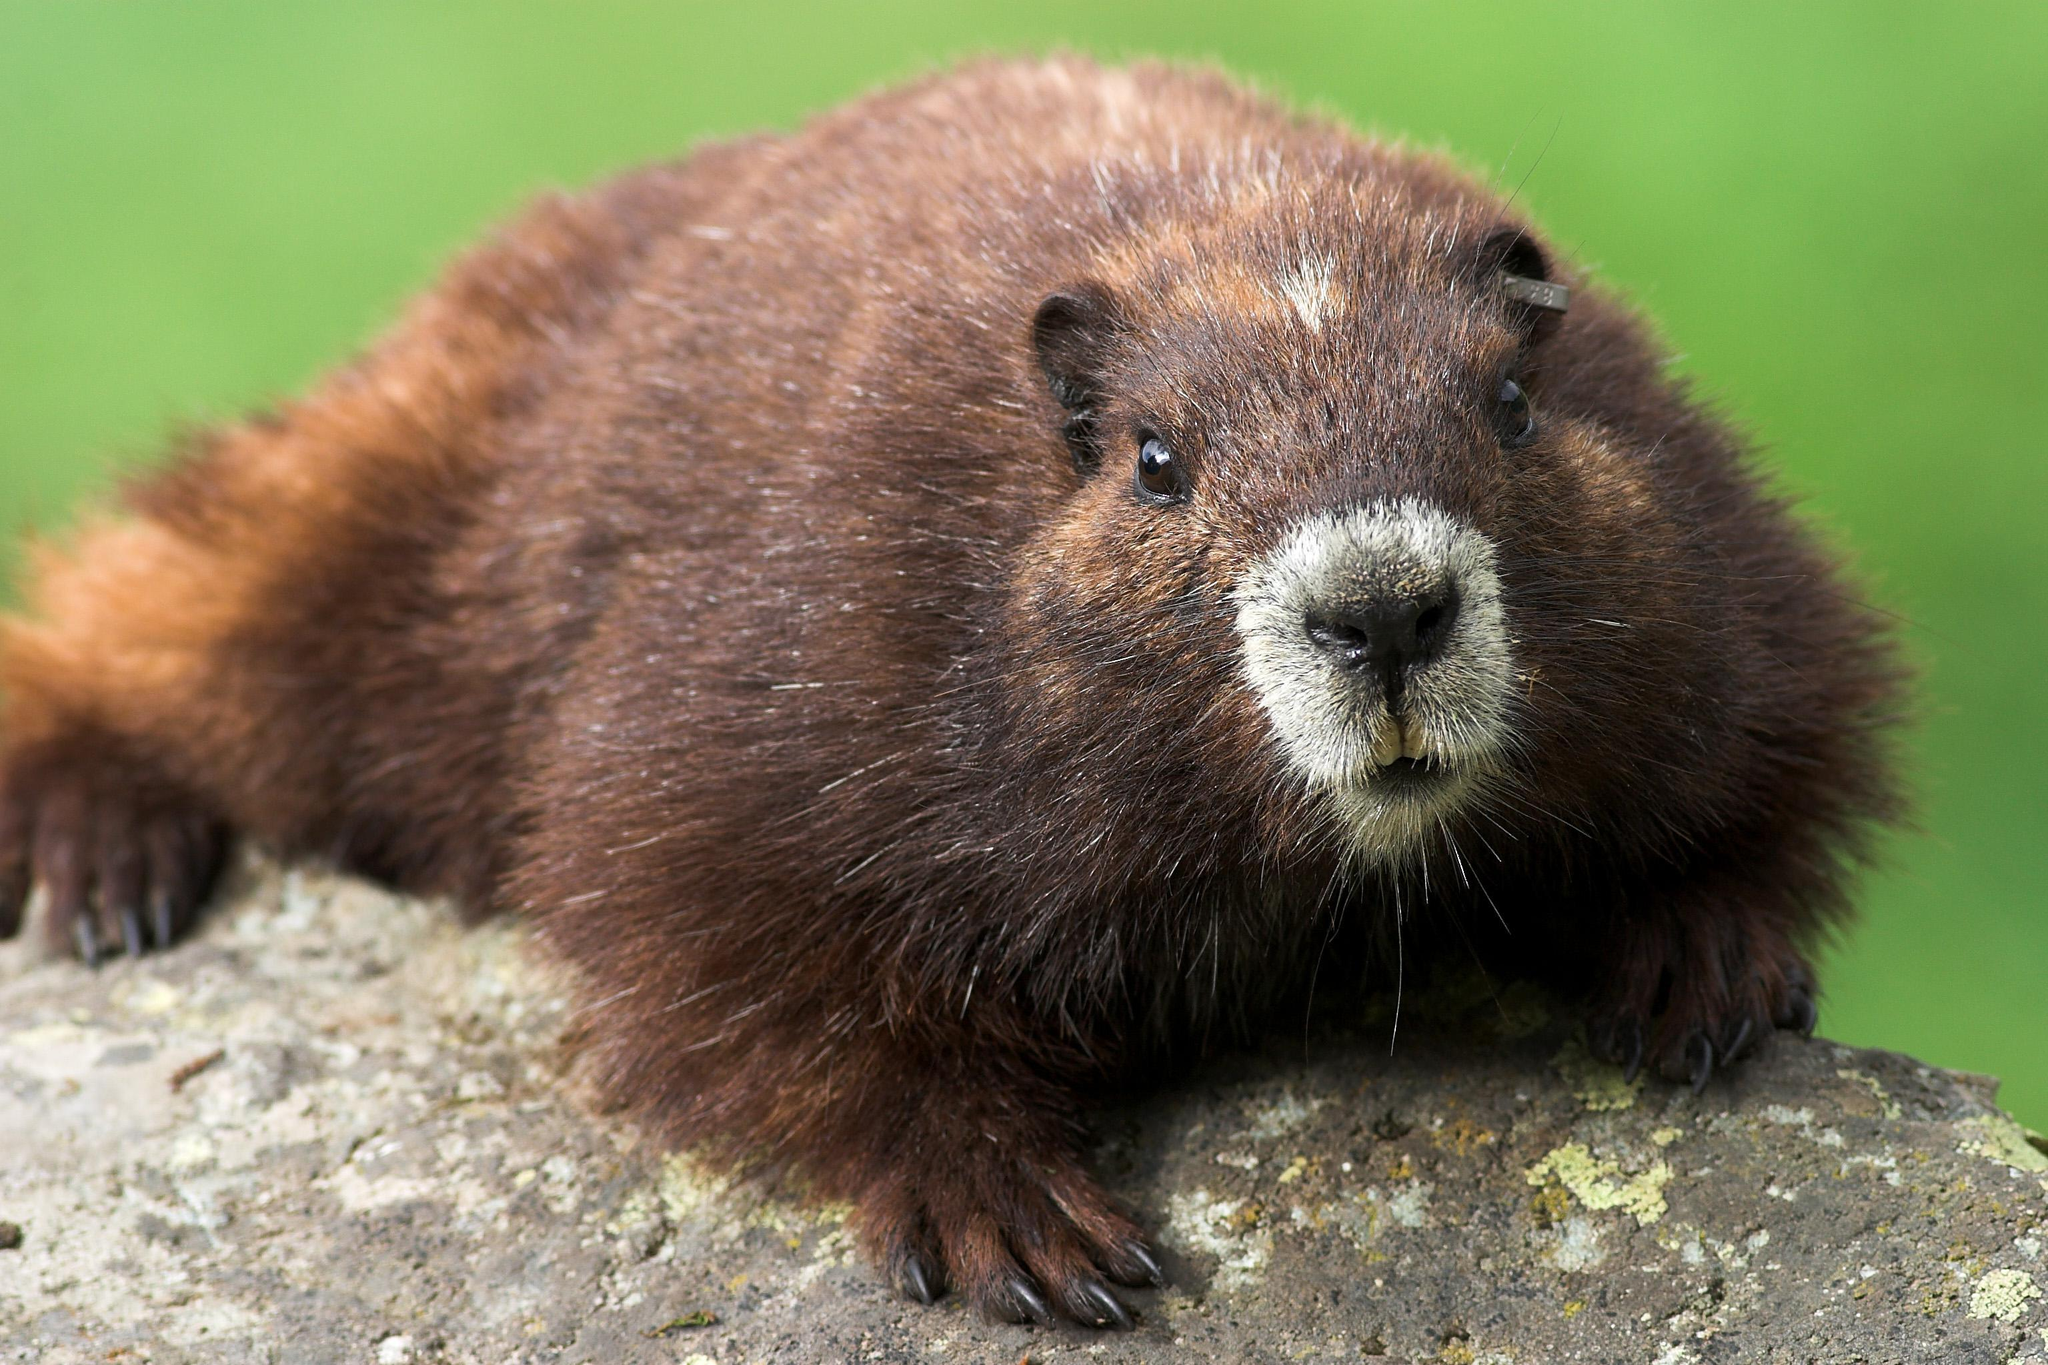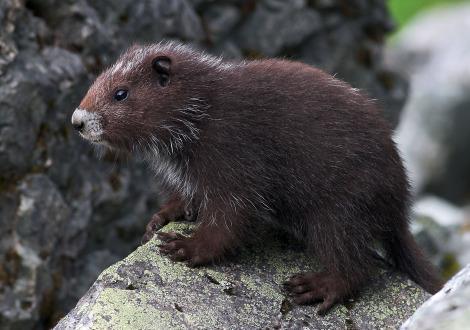The first image is the image on the left, the second image is the image on the right. Assess this claim about the two images: "there are 3 gophers on rocky surfaces in the image pair". Correct or not? Answer yes or no. No. The first image is the image on the left, the second image is the image on the right. For the images shown, is this caption "There are a total of 3 young capybara." true? Answer yes or no. No. 